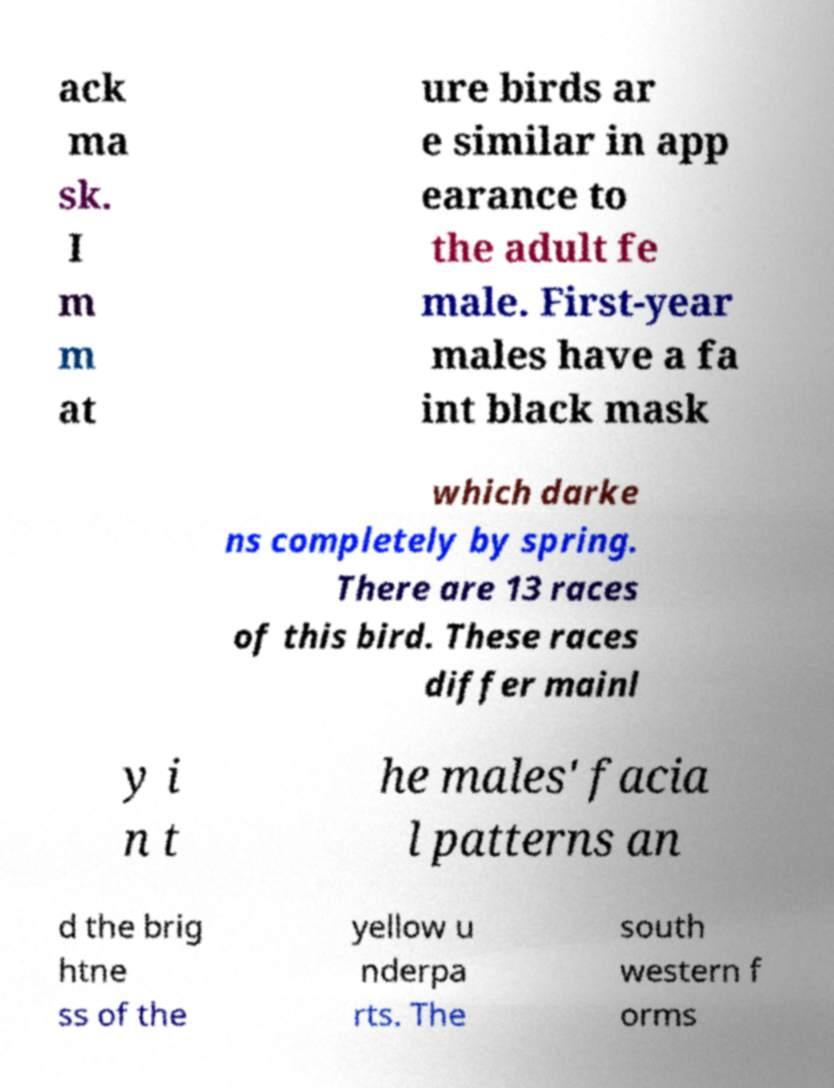Can you read and provide the text displayed in the image?This photo seems to have some interesting text. Can you extract and type it out for me? ack ma sk. I m m at ure birds ar e similar in app earance to the adult fe male. First-year males have a fa int black mask which darke ns completely by spring. There are 13 races of this bird. These races differ mainl y i n t he males' facia l patterns an d the brig htne ss of the yellow u nderpa rts. The south western f orms 